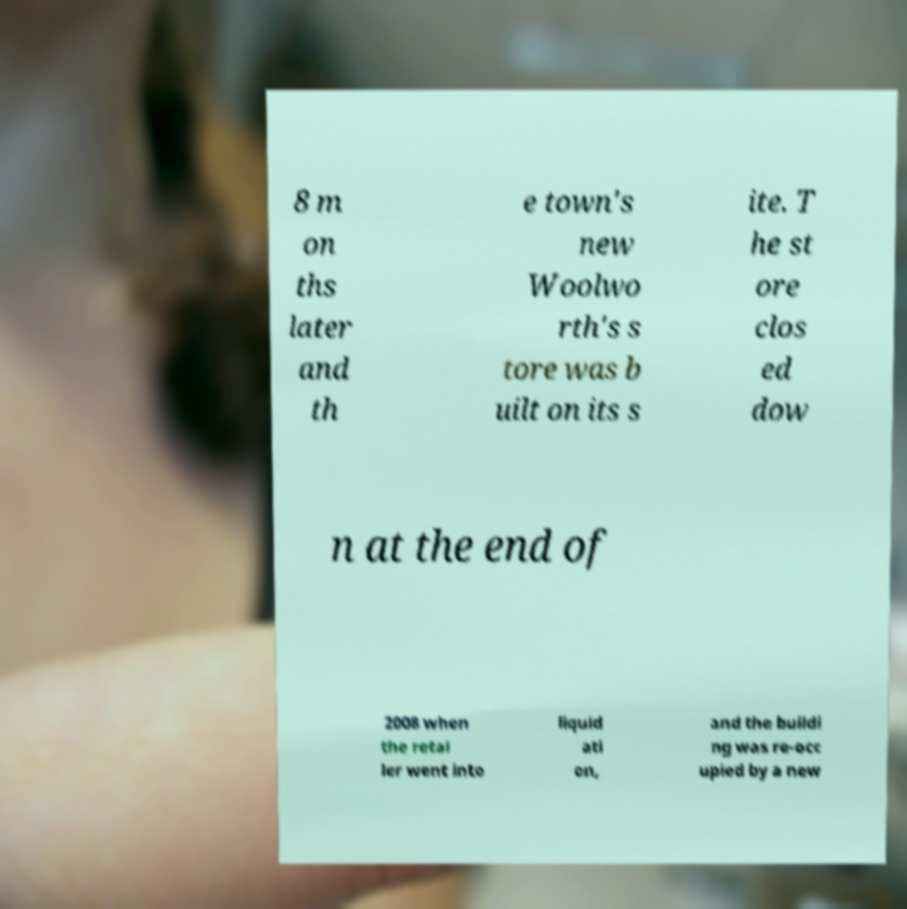What messages or text are displayed in this image? I need them in a readable, typed format. 8 m on ths later and th e town's new Woolwo rth's s tore was b uilt on its s ite. T he st ore clos ed dow n at the end of 2008 when the retai ler went into liquid ati on, and the buildi ng was re-occ upied by a new 